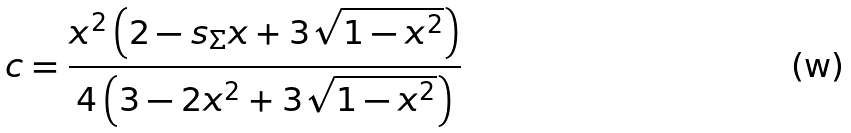Convert formula to latex. <formula><loc_0><loc_0><loc_500><loc_500>c = \frac { x ^ { 2 } \left ( 2 - s _ { \Sigma } x + 3 \sqrt { 1 - x ^ { 2 } } \right ) } { 4 \left ( 3 - 2 x ^ { 2 } + 3 \sqrt { 1 - x ^ { 2 } } \right ) }</formula> 